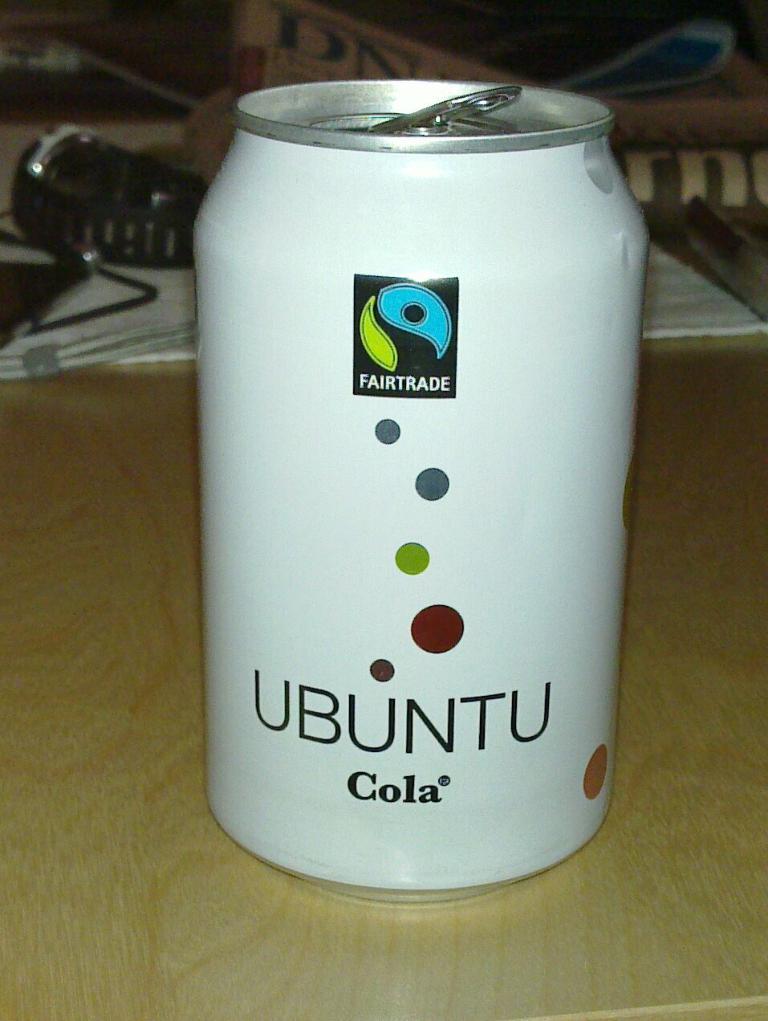What is the name about cola?
Give a very brief answer. Ubuntu. What is the word in the black box?
Your response must be concise. Fairtrade. 